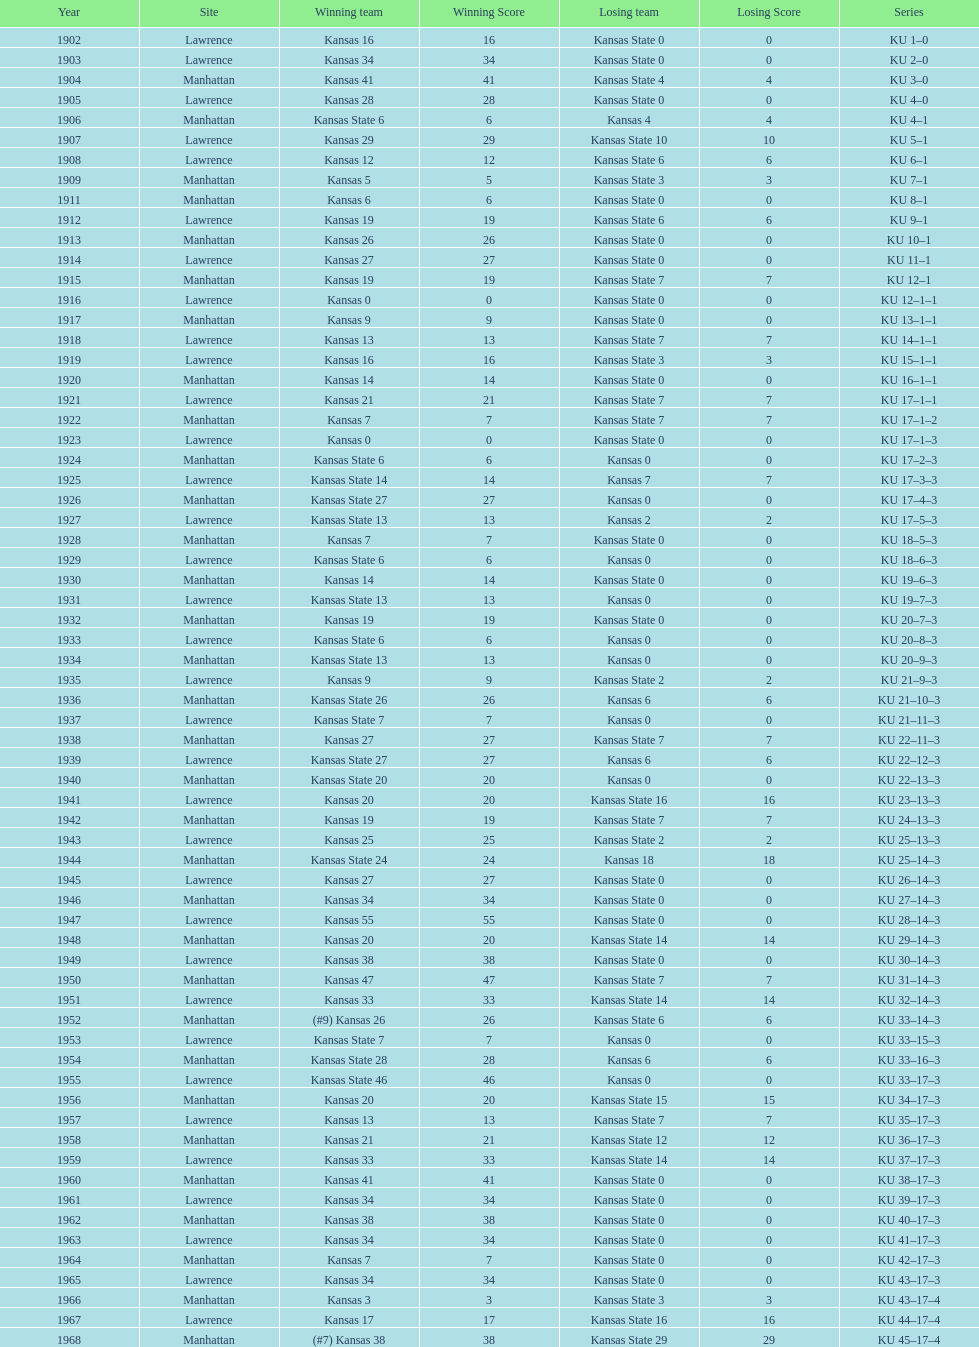When was the last time kansas state lost with 0 points in manhattan? 1964. 